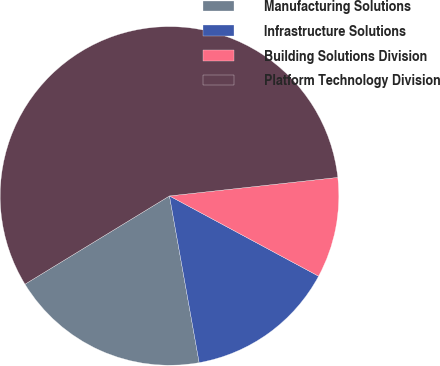Convert chart. <chart><loc_0><loc_0><loc_500><loc_500><pie_chart><fcel>Manufacturing Solutions<fcel>Infrastructure Solutions<fcel>Building Solutions Division<fcel>Platform Technology Division<nl><fcel>19.08%<fcel>14.34%<fcel>9.6%<fcel>56.99%<nl></chart> 